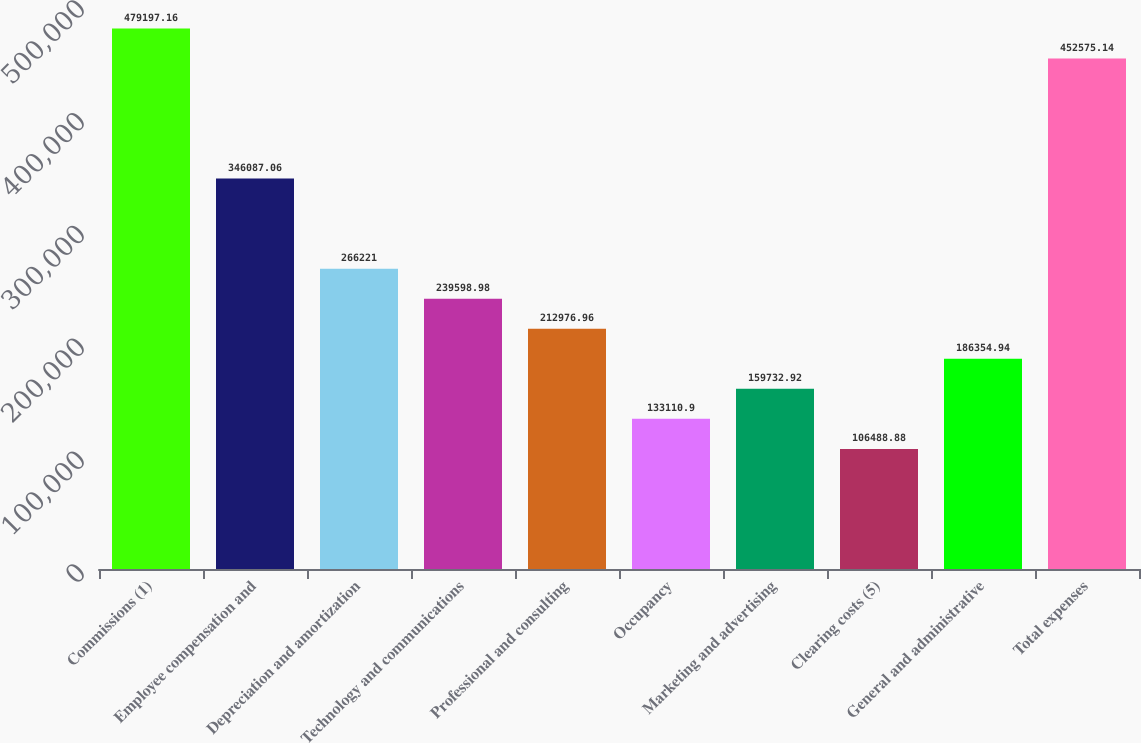Convert chart. <chart><loc_0><loc_0><loc_500><loc_500><bar_chart><fcel>Commissions (1)<fcel>Employee compensation and<fcel>Depreciation and amortization<fcel>Technology and communications<fcel>Professional and consulting<fcel>Occupancy<fcel>Marketing and advertising<fcel>Clearing costs (5)<fcel>General and administrative<fcel>Total expenses<nl><fcel>479197<fcel>346087<fcel>266221<fcel>239599<fcel>212977<fcel>133111<fcel>159733<fcel>106489<fcel>186355<fcel>452575<nl></chart> 